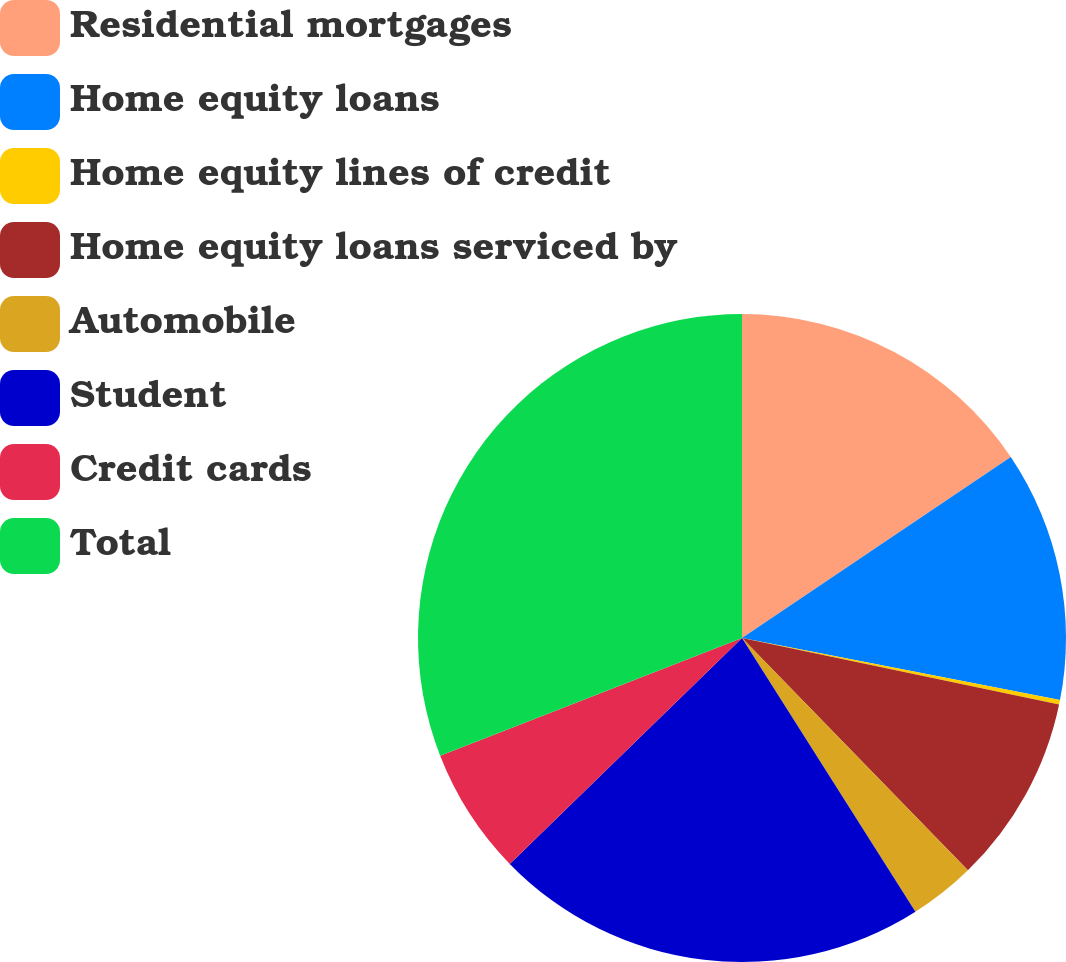<chart> <loc_0><loc_0><loc_500><loc_500><pie_chart><fcel>Residential mortgages<fcel>Home equity loans<fcel>Home equity lines of credit<fcel>Home equity loans serviced by<fcel>Automobile<fcel>Student<fcel>Credit cards<fcel>Total<nl><fcel>15.57%<fcel>12.5%<fcel>0.22%<fcel>9.43%<fcel>3.29%<fcel>21.71%<fcel>6.36%<fcel>30.92%<nl></chart> 